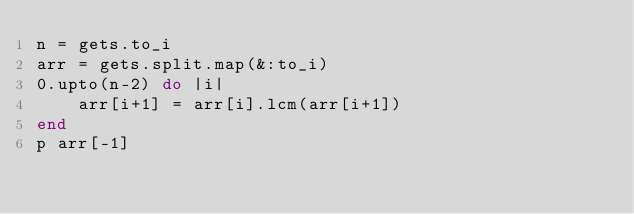Convert code to text. <code><loc_0><loc_0><loc_500><loc_500><_Ruby_>n = gets.to_i
arr = gets.split.map(&:to_i)
0.upto(n-2) do |i|
    arr[i+1] = arr[i].lcm(arr[i+1])
end
p arr[-1]</code> 